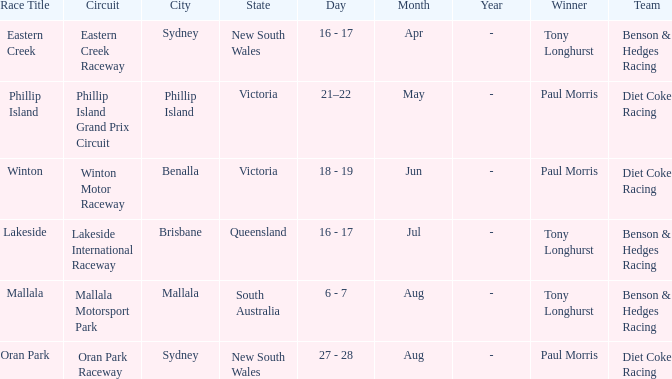Which driver won the Phillip Island Grand Prix Circuit? Paul Morris. 